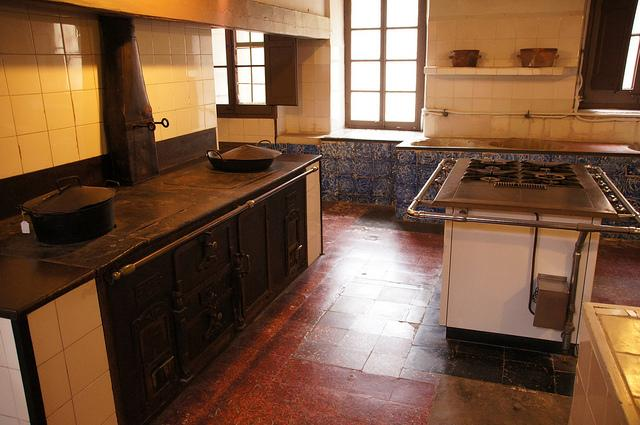Where would a kitchen like this be located? Please explain your reasoning. restaurant. It is heavy duty. 